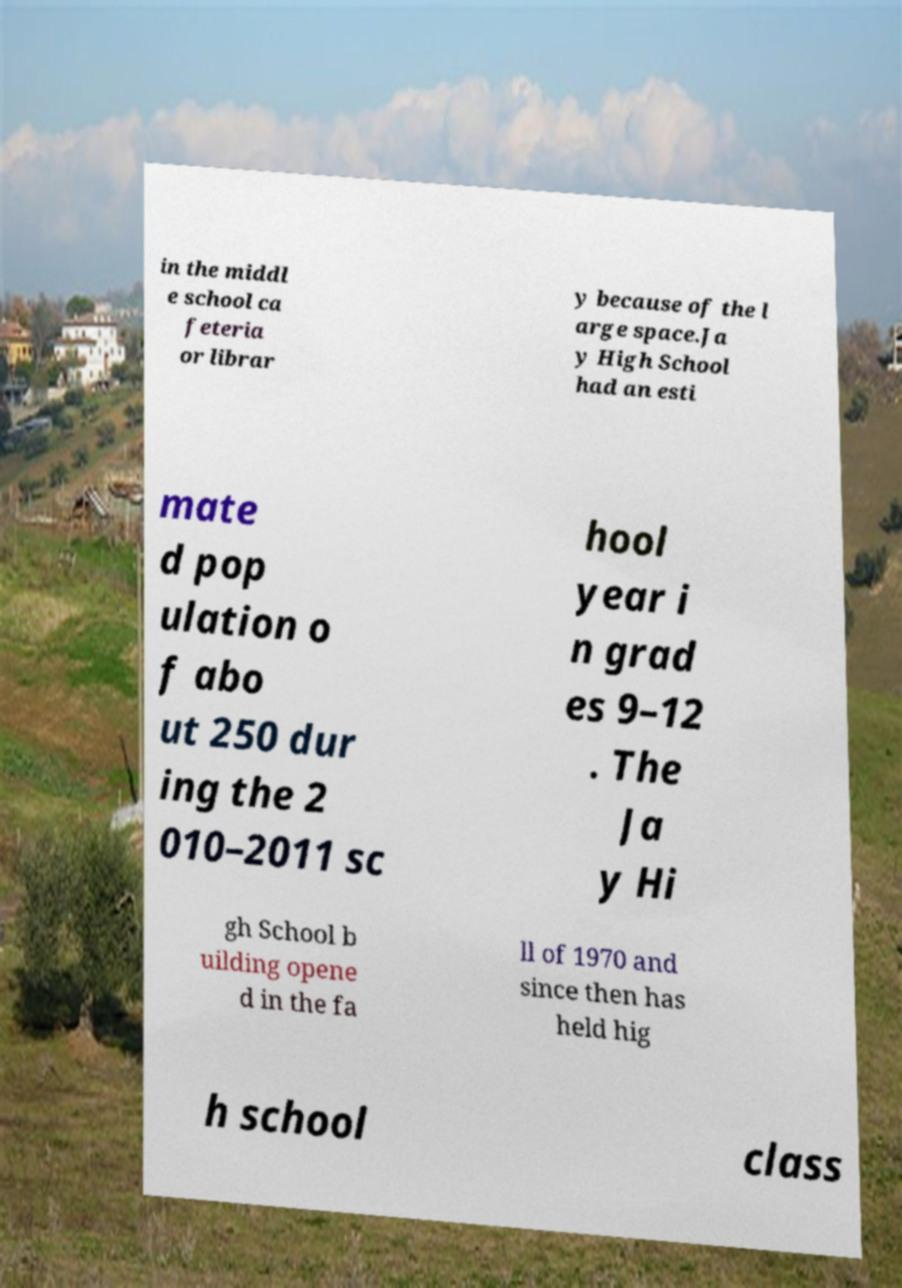For documentation purposes, I need the text within this image transcribed. Could you provide that? in the middl e school ca feteria or librar y because of the l arge space.Ja y High School had an esti mate d pop ulation o f abo ut 250 dur ing the 2 010–2011 sc hool year i n grad es 9–12 . The Ja y Hi gh School b uilding opene d in the fa ll of 1970 and since then has held hig h school class 